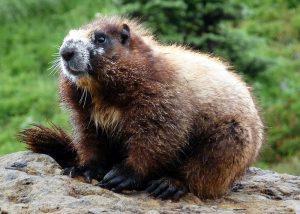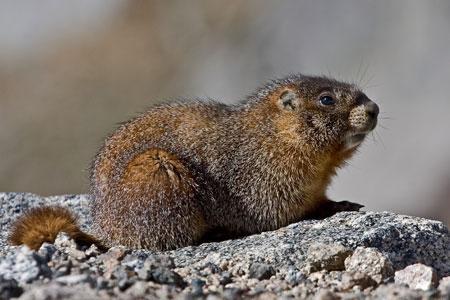The first image is the image on the left, the second image is the image on the right. Examine the images to the left and right. Is the description "The marmots are all a similar color." accurate? Answer yes or no. Yes. The first image is the image on the left, the second image is the image on the right. Evaluate the accuracy of this statement regarding the images: "There are no more than two rodents.". Is it true? Answer yes or no. Yes. 